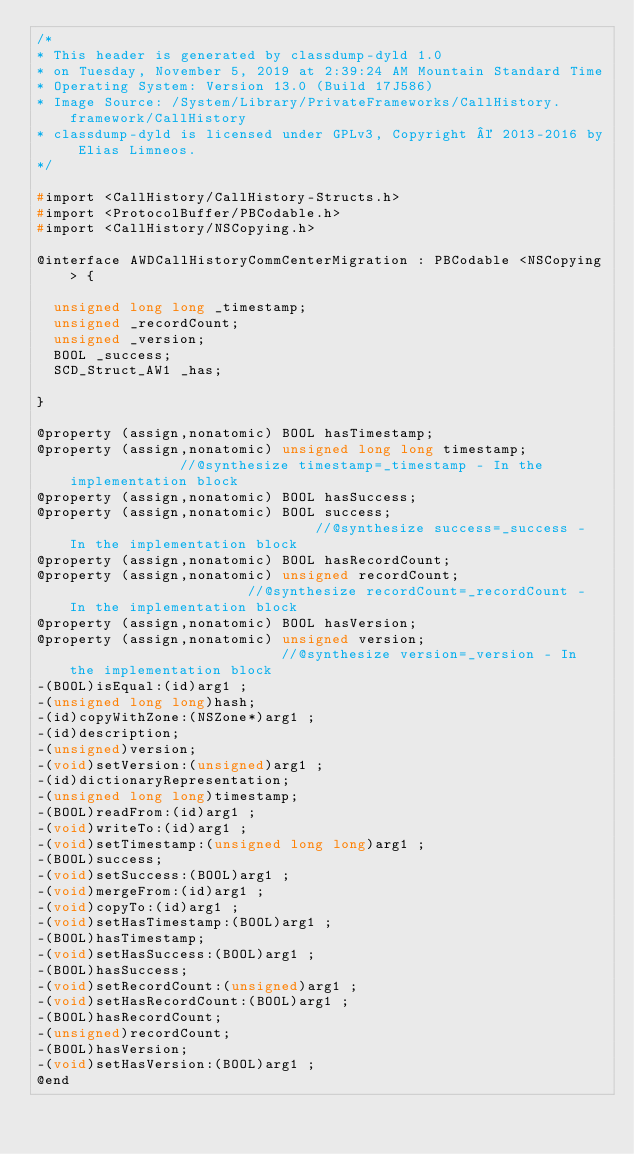Convert code to text. <code><loc_0><loc_0><loc_500><loc_500><_C_>/*
* This header is generated by classdump-dyld 1.0
* on Tuesday, November 5, 2019 at 2:39:24 AM Mountain Standard Time
* Operating System: Version 13.0 (Build 17J586)
* Image Source: /System/Library/PrivateFrameworks/CallHistory.framework/CallHistory
* classdump-dyld is licensed under GPLv3, Copyright © 2013-2016 by Elias Limneos.
*/

#import <CallHistory/CallHistory-Structs.h>
#import <ProtocolBuffer/PBCodable.h>
#import <CallHistory/NSCopying.h>

@interface AWDCallHistoryCommCenterMigration : PBCodable <NSCopying> {

	unsigned long long _timestamp;
	unsigned _recordCount;
	unsigned _version;
	BOOL _success;
	SCD_Struct_AW1 _has;

}

@property (assign,nonatomic) BOOL hasTimestamp; 
@property (assign,nonatomic) unsigned long long timestamp;              //@synthesize timestamp=_timestamp - In the implementation block
@property (assign,nonatomic) BOOL hasSuccess; 
@property (assign,nonatomic) BOOL success;                              //@synthesize success=_success - In the implementation block
@property (assign,nonatomic) BOOL hasRecordCount; 
@property (assign,nonatomic) unsigned recordCount;                      //@synthesize recordCount=_recordCount - In the implementation block
@property (assign,nonatomic) BOOL hasVersion; 
@property (assign,nonatomic) unsigned version;                          //@synthesize version=_version - In the implementation block
-(BOOL)isEqual:(id)arg1 ;
-(unsigned long long)hash;
-(id)copyWithZone:(NSZone*)arg1 ;
-(id)description;
-(unsigned)version;
-(void)setVersion:(unsigned)arg1 ;
-(id)dictionaryRepresentation;
-(unsigned long long)timestamp;
-(BOOL)readFrom:(id)arg1 ;
-(void)writeTo:(id)arg1 ;
-(void)setTimestamp:(unsigned long long)arg1 ;
-(BOOL)success;
-(void)setSuccess:(BOOL)arg1 ;
-(void)mergeFrom:(id)arg1 ;
-(void)copyTo:(id)arg1 ;
-(void)setHasTimestamp:(BOOL)arg1 ;
-(BOOL)hasTimestamp;
-(void)setHasSuccess:(BOOL)arg1 ;
-(BOOL)hasSuccess;
-(void)setRecordCount:(unsigned)arg1 ;
-(void)setHasRecordCount:(BOOL)arg1 ;
-(BOOL)hasRecordCount;
-(unsigned)recordCount;
-(BOOL)hasVersion;
-(void)setHasVersion:(BOOL)arg1 ;
@end

</code> 